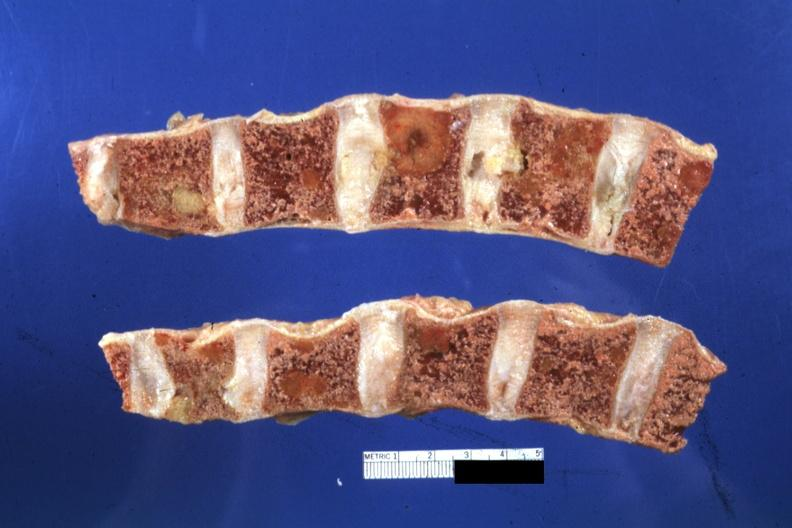s joints present?
Answer the question using a single word or phrase. Yes 